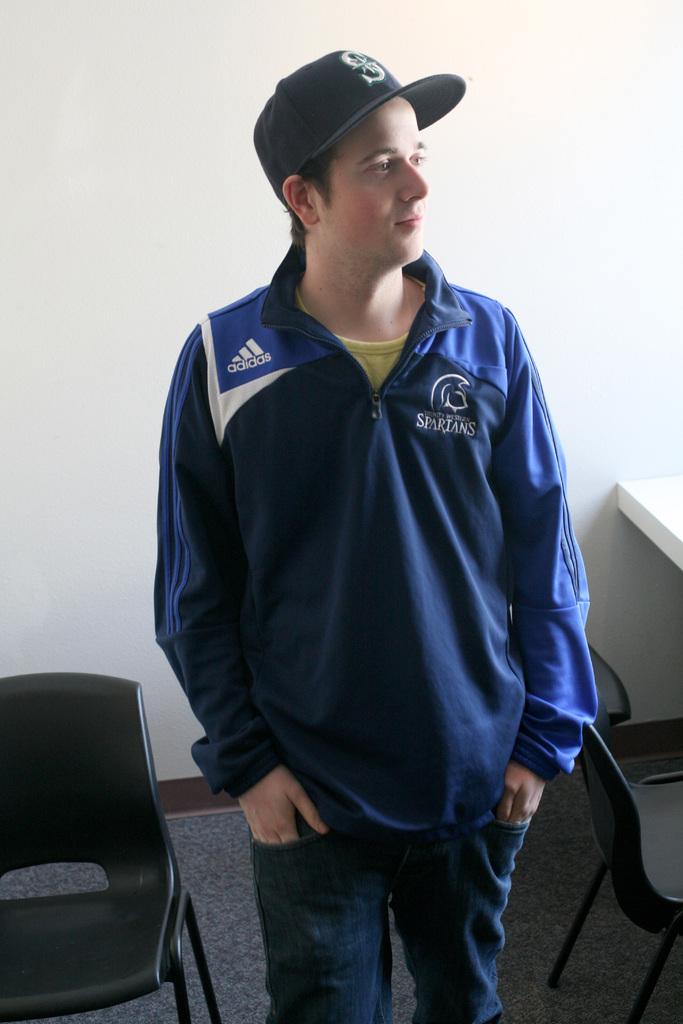What brand of shirt?
Your answer should be very brief. Adidas. 